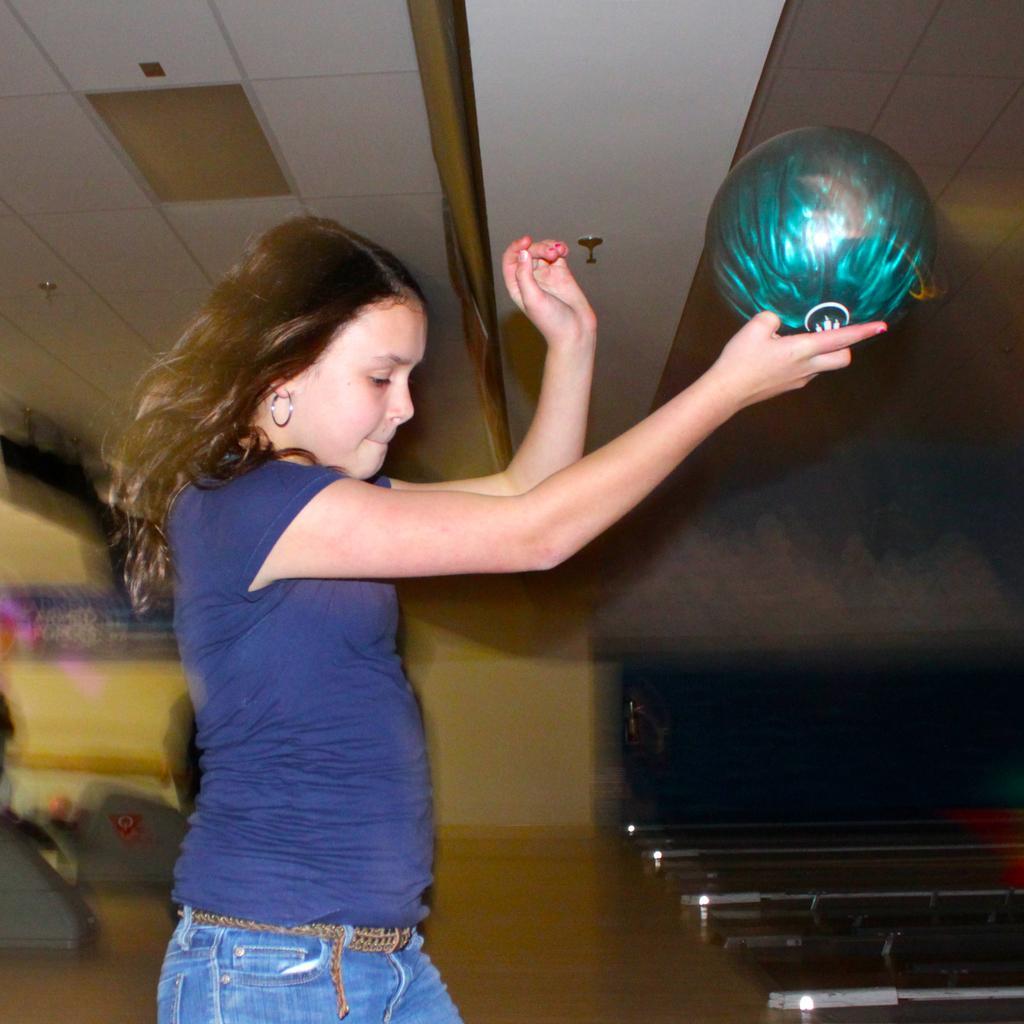Describe this image in one or two sentences. In this picture we can see a girl holding a green ball and standing on the bowling floor. We can see lights on the ceiling. 